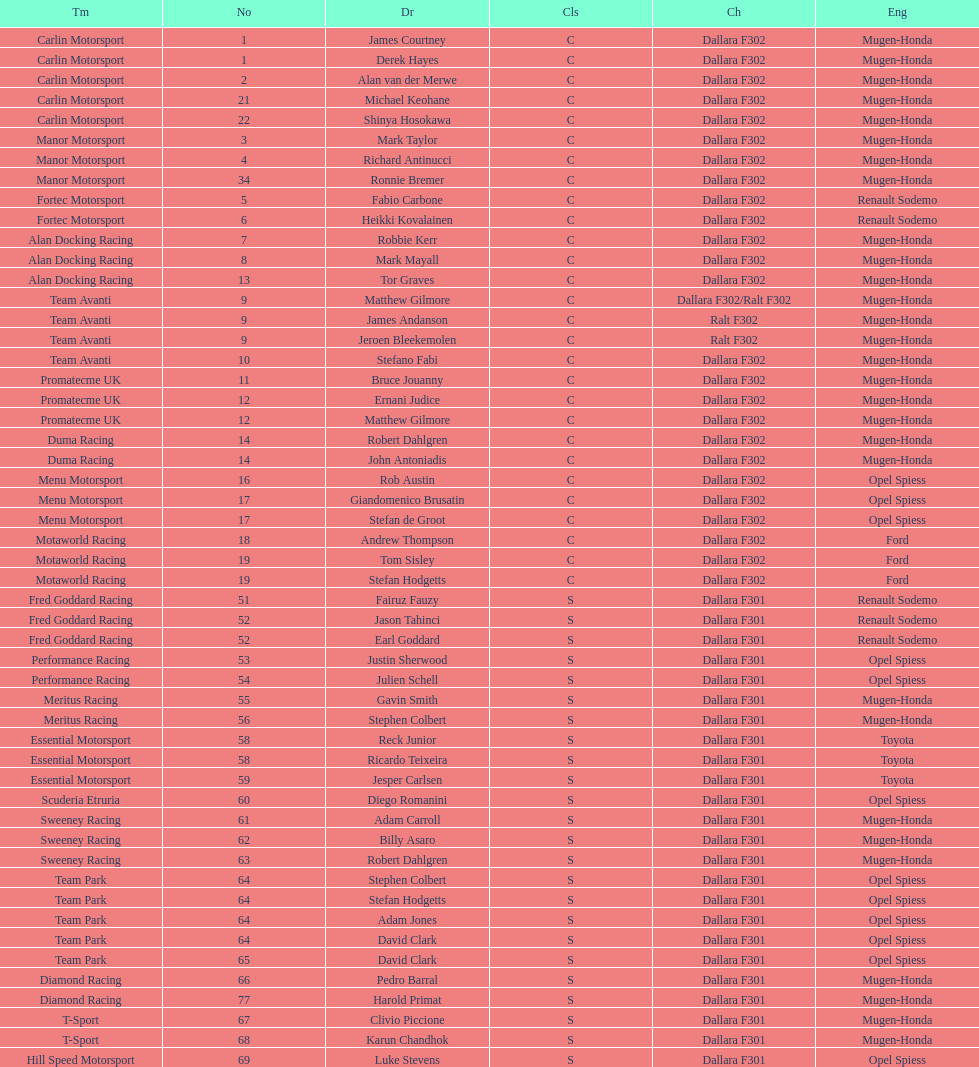Comparing team avanti and motaworld racing, which team had a greater number of drivers? Team Avanti. 